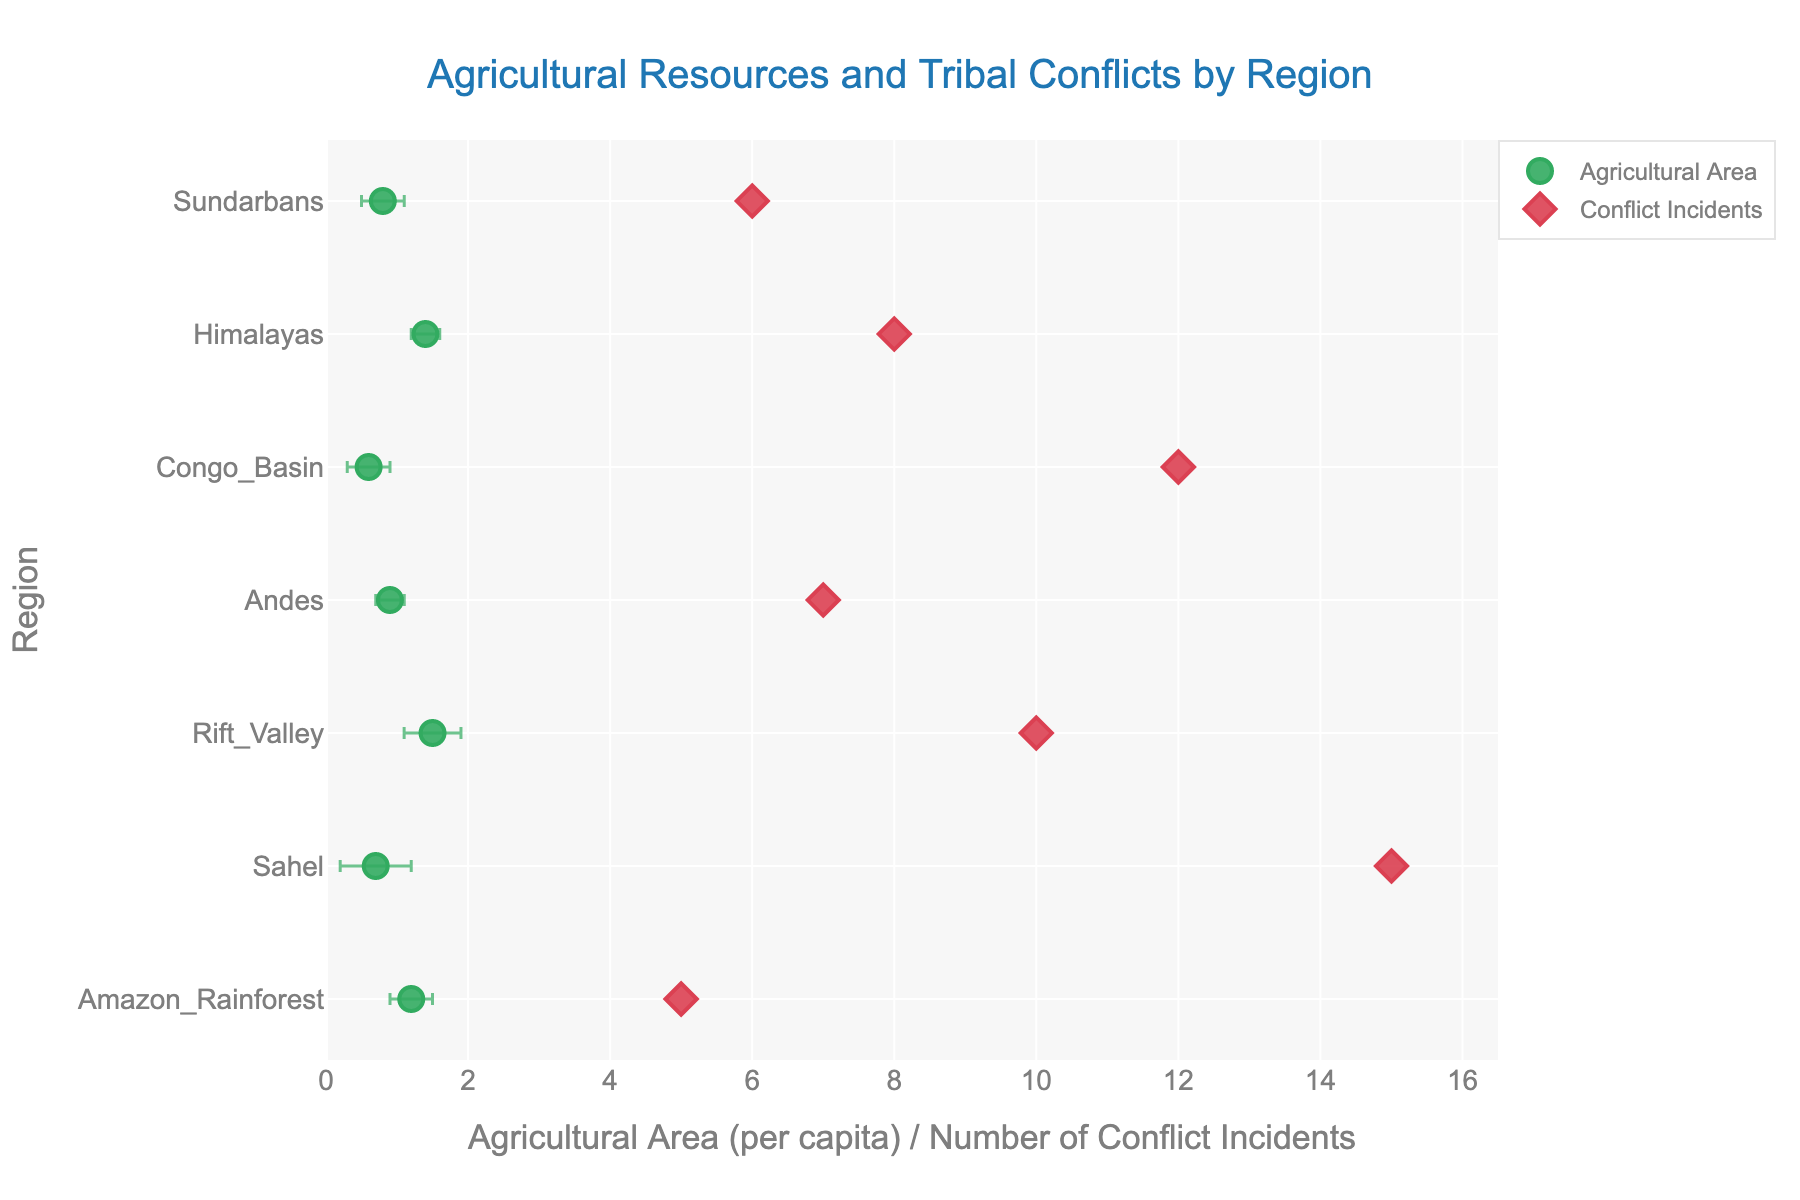What is the title of the plot? The title of the plot can be found at the top center of the figure. It is displayed prominently to provide a brief description of what the plot represents.
Answer: Agricultural Resources and Tribal Conflicts by Region What region has the highest number of conflict incidents? The number of conflict incidents for each region is represented by red diamond markers on the x-axis. By observing the placement of these markers, the region with the highest number of conflict incidents can be determined.
Answer: Sahel Which region has the largest agricultural area per capita? The agricultural area per capita for each region is represented by green circle markers with error bars. By observing the placement of these markers on the x-axis, the region with the largest agricultural area per capita can be identified.
Answer: Rift Valley What is the agricultural area per capita for the Andes? The agricultural area per capita is represented by the green circle markers. Locate the marker positioned horizontally along the x-axis for the Andes.
Answer: 0.9 How many regions are plotted in the figure? Each region is labeled on the y-axis, and each label corresponds to a green circle and red diamond marker. By counting these labels, the number of regions can be determined.
Answer: 7 What regions have conflict incidents fewer than 10? The conflict incidents are represented by red diamond markers. By identifying the markers positioned below 10 on the x-axis, the regions with fewer conflict incidents are found.
Answer: Amazon Rainforest, Andes, Himalayas, Sundarbans Which two regions have the most similar agricultural areas per capita? By examining the green circle markers, identify the two markers that are closest to each other on the x-axis.
Answer: Andes and Sundarbans Which region shows the highest standard error for agricultural area per capita? The standard error is represented by the length of the horizontal error bars connected to the green circle markers. By comparing these lengths, the region with the highest standard error can be identified.
Answer: Sahel What is the difference between the agricultural area per capita in the Amazon Rainforest and the Congo Basin? Identify the green circle markers for both Amazon Rainforest and Congo Basin and note their positions on the x-axis. Subtract the value of Congo Basin’s area from Amazon Rainforest's area.
Answer: 0.6 Compare the conflict incidents between the Andes and Sundarbans. Which region has more, and by how much? Locate the red diamond markers for both Andes and Sundarbans, note their positions on the x-axis, and calculate the difference between these values.
Answer: Andes has more by 1 